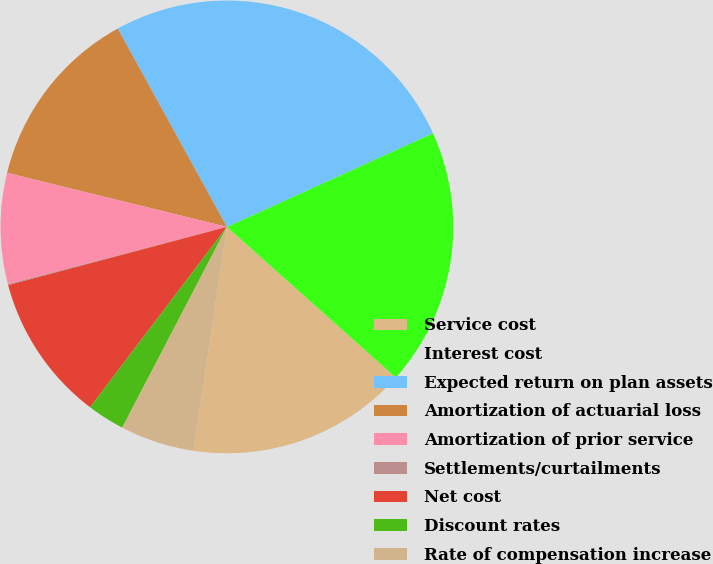Convert chart. <chart><loc_0><loc_0><loc_500><loc_500><pie_chart><fcel>Service cost<fcel>Interest cost<fcel>Expected return on plan assets<fcel>Amortization of actuarial loss<fcel>Amortization of prior service<fcel>Settlements/curtailments<fcel>Net cost<fcel>Discount rates<fcel>Rate of compensation increase<nl><fcel>15.76%<fcel>18.38%<fcel>26.22%<fcel>13.15%<fcel>7.91%<fcel>0.07%<fcel>10.53%<fcel>2.68%<fcel>5.3%<nl></chart> 